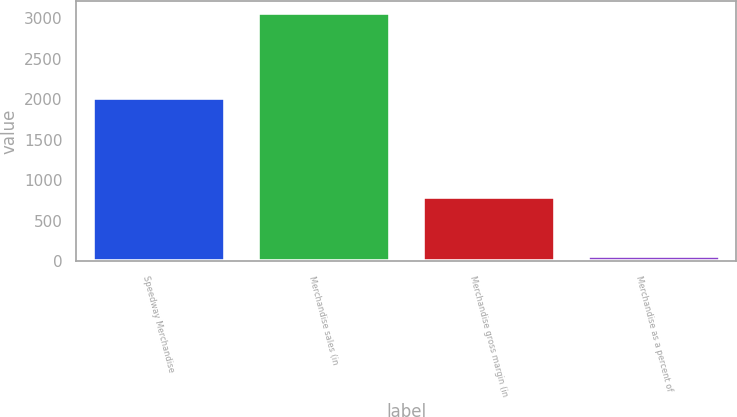Convert chart. <chart><loc_0><loc_0><loc_500><loc_500><bar_chart><fcel>Speedway Merchandise<fcel>Merchandise sales (in<fcel>Merchandise gross margin (in<fcel>Merchandise as a percent of<nl><fcel>2012<fcel>3058<fcel>795<fcel>67<nl></chart> 